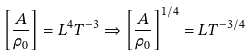<formula> <loc_0><loc_0><loc_500><loc_500>\left [ \frac { A } { \rho _ { 0 } } \right ] = L ^ { 4 } T ^ { - 3 } \Rightarrow \left [ \frac { A } { \rho _ { 0 } } \right ] ^ { 1 / 4 } = L T ^ { - 3 / 4 }</formula> 